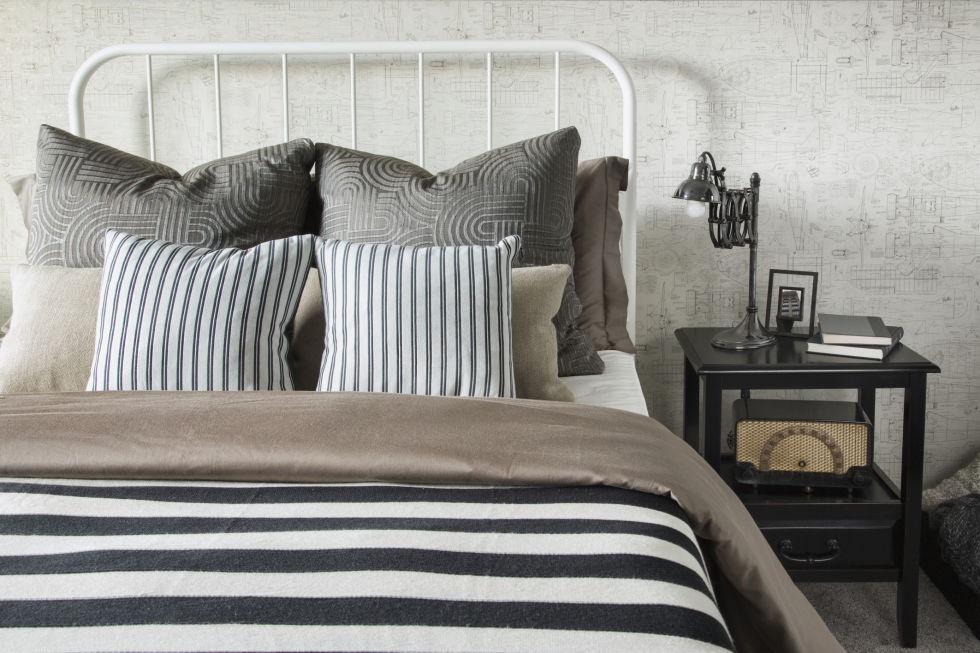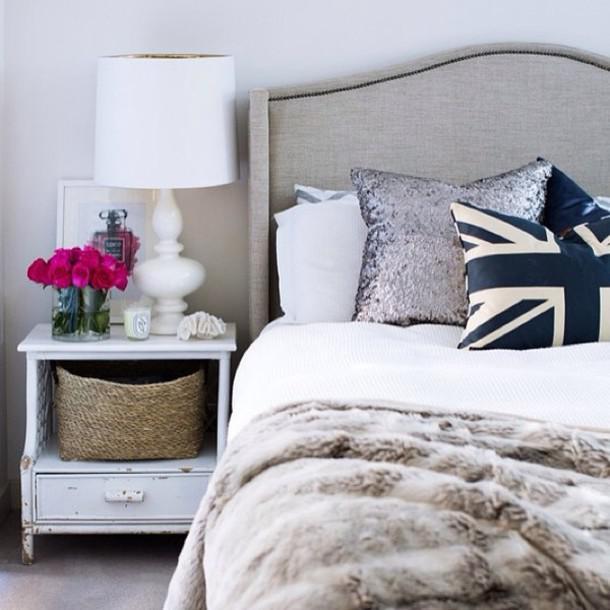The first image is the image on the left, the second image is the image on the right. Analyze the images presented: Is the assertion "On the wall above the headboard of one bed is a round decorative object." valid? Answer yes or no. No. 